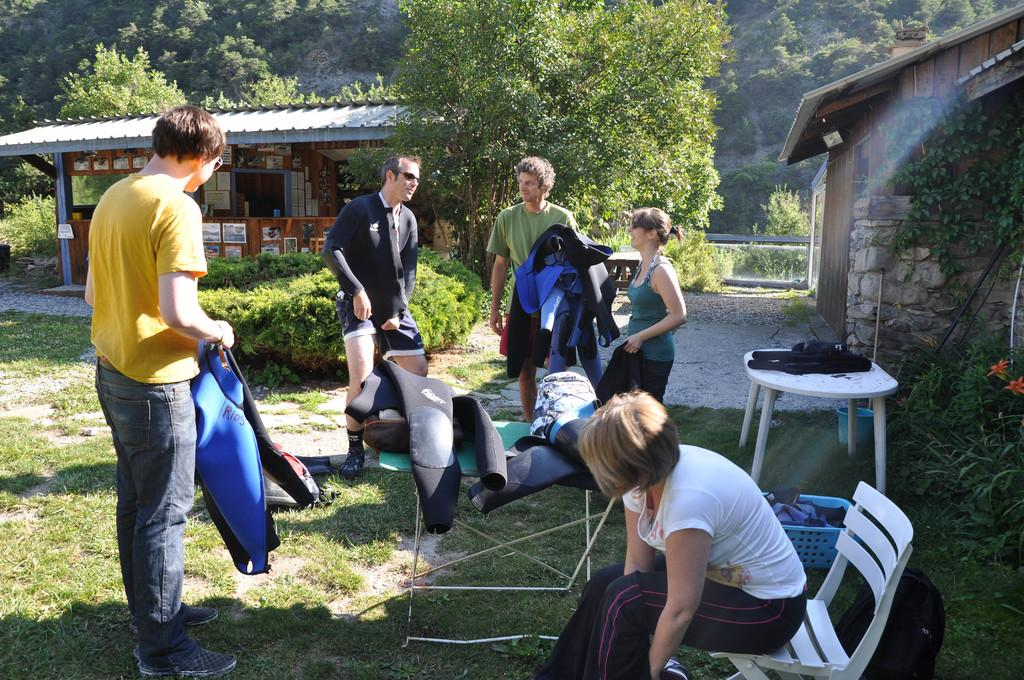Who or what can be seen in the image? There are people in the image. What can be seen in the distance behind the people? There are houses and trees in the background of the image. What is at the bottom of the image? There is grass at the bottom of the image. What are some people wearing in the image? Some people are wearing swimsuits. What piece of furniture is present in the image? There is a table in the image. What happens to the earth when the people in the image burst into laughter? The image does not show the people bursting into laughter, nor does it depict any changes to the earth. 